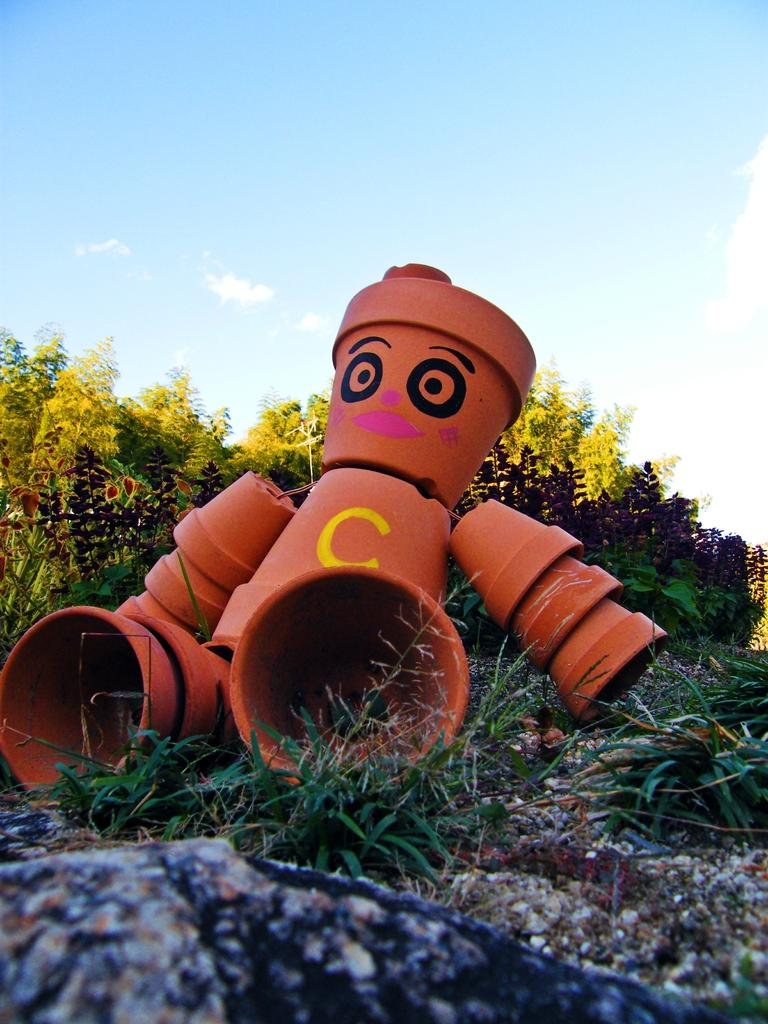What can be seen in the foreground of the picture? In the foreground of the picture, there are shrubs, soil, a rock, and buckets. What type of vegetation is present in the foreground? Shrubs are the type of vegetation present in the foreground. What else is visible in the foreground besides the shrubs? Soil, a rock, and buckets are also visible in the foreground. What can be seen in the background of the picture? There are trees in the background of the picture. What is visible at the top of the image? The sky is visible at the top of the image. How many bubbles are floating around the rock in the image? There are no bubbles present in the image; the image only shows shrubs, soil, a rock, buckets, trees, and the sky. What type of blade is being used to trim the shrubs in the image? There is no blade visible in the image, and the shrubs do not appear to be trimmed. 